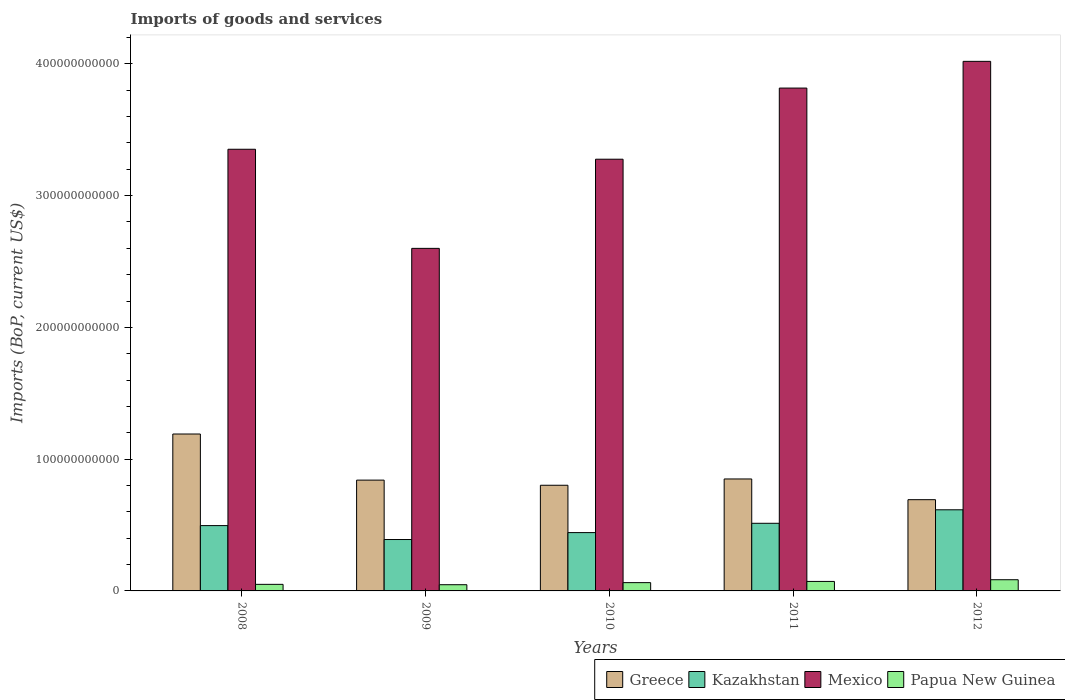How many groups of bars are there?
Your answer should be compact. 5. Are the number of bars per tick equal to the number of legend labels?
Your response must be concise. Yes. What is the label of the 1st group of bars from the left?
Provide a short and direct response. 2008. What is the amount spent on imports in Mexico in 2011?
Your response must be concise. 3.82e+11. Across all years, what is the maximum amount spent on imports in Mexico?
Offer a terse response. 4.02e+11. Across all years, what is the minimum amount spent on imports in Kazakhstan?
Offer a very short reply. 3.90e+1. In which year was the amount spent on imports in Papua New Guinea maximum?
Your response must be concise. 2012. What is the total amount spent on imports in Papua New Guinea in the graph?
Your answer should be very brief. 3.17e+1. What is the difference between the amount spent on imports in Kazakhstan in 2008 and that in 2012?
Keep it short and to the point. -1.20e+1. What is the difference between the amount spent on imports in Kazakhstan in 2008 and the amount spent on imports in Papua New Guinea in 2011?
Offer a terse response. 4.24e+1. What is the average amount spent on imports in Mexico per year?
Offer a terse response. 3.41e+11. In the year 2012, what is the difference between the amount spent on imports in Mexico and amount spent on imports in Greece?
Ensure brevity in your answer.  3.33e+11. In how many years, is the amount spent on imports in Kazakhstan greater than 160000000000 US$?
Keep it short and to the point. 0. What is the ratio of the amount spent on imports in Kazakhstan in 2009 to that in 2012?
Offer a terse response. 0.63. Is the difference between the amount spent on imports in Mexico in 2009 and 2010 greater than the difference between the amount spent on imports in Greece in 2009 and 2010?
Make the answer very short. No. What is the difference between the highest and the second highest amount spent on imports in Greece?
Provide a succinct answer. 3.41e+1. What is the difference between the highest and the lowest amount spent on imports in Kazakhstan?
Provide a succinct answer. 2.26e+1. What does the 1st bar from the left in 2009 represents?
Your response must be concise. Greece. What does the 3rd bar from the right in 2012 represents?
Provide a short and direct response. Kazakhstan. Is it the case that in every year, the sum of the amount spent on imports in Greece and amount spent on imports in Mexico is greater than the amount spent on imports in Kazakhstan?
Provide a short and direct response. Yes. How many bars are there?
Offer a very short reply. 20. Are all the bars in the graph horizontal?
Your answer should be very brief. No. What is the difference between two consecutive major ticks on the Y-axis?
Your response must be concise. 1.00e+11. Are the values on the major ticks of Y-axis written in scientific E-notation?
Give a very brief answer. No. Where does the legend appear in the graph?
Your answer should be very brief. Bottom right. How are the legend labels stacked?
Your response must be concise. Horizontal. What is the title of the graph?
Give a very brief answer. Imports of goods and services. What is the label or title of the X-axis?
Provide a short and direct response. Years. What is the label or title of the Y-axis?
Your answer should be very brief. Imports (BoP, current US$). What is the Imports (BoP, current US$) in Greece in 2008?
Provide a succinct answer. 1.19e+11. What is the Imports (BoP, current US$) of Kazakhstan in 2008?
Offer a terse response. 4.96e+1. What is the Imports (BoP, current US$) in Mexico in 2008?
Your answer should be very brief. 3.35e+11. What is the Imports (BoP, current US$) in Papua New Guinea in 2008?
Offer a terse response. 4.98e+09. What is the Imports (BoP, current US$) of Greece in 2009?
Make the answer very short. 8.41e+1. What is the Imports (BoP, current US$) in Kazakhstan in 2009?
Offer a very short reply. 3.90e+1. What is the Imports (BoP, current US$) in Mexico in 2009?
Keep it short and to the point. 2.60e+11. What is the Imports (BoP, current US$) in Papua New Guinea in 2009?
Ensure brevity in your answer.  4.71e+09. What is the Imports (BoP, current US$) of Greece in 2010?
Your answer should be very brief. 8.02e+1. What is the Imports (BoP, current US$) of Kazakhstan in 2010?
Give a very brief answer. 4.43e+1. What is the Imports (BoP, current US$) of Mexico in 2010?
Ensure brevity in your answer.  3.28e+11. What is the Imports (BoP, current US$) in Papua New Guinea in 2010?
Make the answer very short. 6.29e+09. What is the Imports (BoP, current US$) of Greece in 2011?
Offer a very short reply. 8.50e+1. What is the Imports (BoP, current US$) in Kazakhstan in 2011?
Provide a succinct answer. 5.13e+1. What is the Imports (BoP, current US$) of Mexico in 2011?
Give a very brief answer. 3.82e+11. What is the Imports (BoP, current US$) of Papua New Guinea in 2011?
Keep it short and to the point. 7.21e+09. What is the Imports (BoP, current US$) of Greece in 2012?
Offer a very short reply. 6.92e+1. What is the Imports (BoP, current US$) of Kazakhstan in 2012?
Offer a very short reply. 6.16e+1. What is the Imports (BoP, current US$) of Mexico in 2012?
Your answer should be very brief. 4.02e+11. What is the Imports (BoP, current US$) of Papua New Guinea in 2012?
Your answer should be compact. 8.50e+09. Across all years, what is the maximum Imports (BoP, current US$) in Greece?
Your response must be concise. 1.19e+11. Across all years, what is the maximum Imports (BoP, current US$) in Kazakhstan?
Give a very brief answer. 6.16e+1. Across all years, what is the maximum Imports (BoP, current US$) in Mexico?
Provide a succinct answer. 4.02e+11. Across all years, what is the maximum Imports (BoP, current US$) in Papua New Guinea?
Offer a terse response. 8.50e+09. Across all years, what is the minimum Imports (BoP, current US$) in Greece?
Provide a short and direct response. 6.92e+1. Across all years, what is the minimum Imports (BoP, current US$) in Kazakhstan?
Make the answer very short. 3.90e+1. Across all years, what is the minimum Imports (BoP, current US$) of Mexico?
Give a very brief answer. 2.60e+11. Across all years, what is the minimum Imports (BoP, current US$) in Papua New Guinea?
Your response must be concise. 4.71e+09. What is the total Imports (BoP, current US$) in Greece in the graph?
Your answer should be compact. 4.38e+11. What is the total Imports (BoP, current US$) in Kazakhstan in the graph?
Make the answer very short. 2.46e+11. What is the total Imports (BoP, current US$) of Mexico in the graph?
Ensure brevity in your answer.  1.71e+12. What is the total Imports (BoP, current US$) in Papua New Guinea in the graph?
Give a very brief answer. 3.17e+1. What is the difference between the Imports (BoP, current US$) in Greece in 2008 and that in 2009?
Your answer should be compact. 3.50e+1. What is the difference between the Imports (BoP, current US$) of Kazakhstan in 2008 and that in 2009?
Your answer should be compact. 1.06e+1. What is the difference between the Imports (BoP, current US$) in Mexico in 2008 and that in 2009?
Keep it short and to the point. 7.52e+1. What is the difference between the Imports (BoP, current US$) of Papua New Guinea in 2008 and that in 2009?
Your answer should be compact. 2.73e+08. What is the difference between the Imports (BoP, current US$) of Greece in 2008 and that in 2010?
Provide a succinct answer. 3.89e+1. What is the difference between the Imports (BoP, current US$) of Kazakhstan in 2008 and that in 2010?
Give a very brief answer. 5.31e+09. What is the difference between the Imports (BoP, current US$) in Mexico in 2008 and that in 2010?
Offer a very short reply. 7.56e+09. What is the difference between the Imports (BoP, current US$) of Papua New Guinea in 2008 and that in 2010?
Offer a terse response. -1.30e+09. What is the difference between the Imports (BoP, current US$) of Greece in 2008 and that in 2011?
Offer a terse response. 3.41e+1. What is the difference between the Imports (BoP, current US$) of Kazakhstan in 2008 and that in 2011?
Your response must be concise. -1.75e+09. What is the difference between the Imports (BoP, current US$) of Mexico in 2008 and that in 2011?
Your answer should be compact. -4.64e+1. What is the difference between the Imports (BoP, current US$) in Papua New Guinea in 2008 and that in 2011?
Provide a succinct answer. -2.22e+09. What is the difference between the Imports (BoP, current US$) of Greece in 2008 and that in 2012?
Ensure brevity in your answer.  4.98e+1. What is the difference between the Imports (BoP, current US$) of Kazakhstan in 2008 and that in 2012?
Make the answer very short. -1.20e+1. What is the difference between the Imports (BoP, current US$) in Mexico in 2008 and that in 2012?
Provide a succinct answer. -6.67e+1. What is the difference between the Imports (BoP, current US$) in Papua New Guinea in 2008 and that in 2012?
Give a very brief answer. -3.52e+09. What is the difference between the Imports (BoP, current US$) of Greece in 2009 and that in 2010?
Ensure brevity in your answer.  3.90e+09. What is the difference between the Imports (BoP, current US$) in Kazakhstan in 2009 and that in 2010?
Your response must be concise. -5.26e+09. What is the difference between the Imports (BoP, current US$) of Mexico in 2009 and that in 2010?
Your answer should be very brief. -6.77e+1. What is the difference between the Imports (BoP, current US$) of Papua New Guinea in 2009 and that in 2010?
Provide a succinct answer. -1.57e+09. What is the difference between the Imports (BoP, current US$) in Greece in 2009 and that in 2011?
Your answer should be compact. -8.84e+08. What is the difference between the Imports (BoP, current US$) in Kazakhstan in 2009 and that in 2011?
Offer a very short reply. -1.23e+1. What is the difference between the Imports (BoP, current US$) of Mexico in 2009 and that in 2011?
Provide a succinct answer. -1.22e+11. What is the difference between the Imports (BoP, current US$) of Papua New Guinea in 2009 and that in 2011?
Give a very brief answer. -2.49e+09. What is the difference between the Imports (BoP, current US$) of Greece in 2009 and that in 2012?
Provide a short and direct response. 1.48e+1. What is the difference between the Imports (BoP, current US$) of Kazakhstan in 2009 and that in 2012?
Give a very brief answer. -2.26e+1. What is the difference between the Imports (BoP, current US$) of Mexico in 2009 and that in 2012?
Offer a terse response. -1.42e+11. What is the difference between the Imports (BoP, current US$) of Papua New Guinea in 2009 and that in 2012?
Provide a succinct answer. -3.79e+09. What is the difference between the Imports (BoP, current US$) in Greece in 2010 and that in 2011?
Your answer should be very brief. -4.79e+09. What is the difference between the Imports (BoP, current US$) of Kazakhstan in 2010 and that in 2011?
Your answer should be very brief. -7.06e+09. What is the difference between the Imports (BoP, current US$) of Mexico in 2010 and that in 2011?
Keep it short and to the point. -5.40e+1. What is the difference between the Imports (BoP, current US$) of Papua New Guinea in 2010 and that in 2011?
Provide a short and direct response. -9.20e+08. What is the difference between the Imports (BoP, current US$) of Greece in 2010 and that in 2012?
Give a very brief answer. 1.09e+1. What is the difference between the Imports (BoP, current US$) of Kazakhstan in 2010 and that in 2012?
Offer a terse response. -1.73e+1. What is the difference between the Imports (BoP, current US$) of Mexico in 2010 and that in 2012?
Provide a succinct answer. -7.43e+1. What is the difference between the Imports (BoP, current US$) of Papua New Guinea in 2010 and that in 2012?
Offer a terse response. -2.21e+09. What is the difference between the Imports (BoP, current US$) of Greece in 2011 and that in 2012?
Give a very brief answer. 1.57e+1. What is the difference between the Imports (BoP, current US$) of Kazakhstan in 2011 and that in 2012?
Give a very brief answer. -1.02e+1. What is the difference between the Imports (BoP, current US$) of Mexico in 2011 and that in 2012?
Provide a succinct answer. -2.03e+1. What is the difference between the Imports (BoP, current US$) of Papua New Guinea in 2011 and that in 2012?
Provide a succinct answer. -1.29e+09. What is the difference between the Imports (BoP, current US$) of Greece in 2008 and the Imports (BoP, current US$) of Kazakhstan in 2009?
Keep it short and to the point. 8.01e+1. What is the difference between the Imports (BoP, current US$) in Greece in 2008 and the Imports (BoP, current US$) in Mexico in 2009?
Your answer should be very brief. -1.41e+11. What is the difference between the Imports (BoP, current US$) in Greece in 2008 and the Imports (BoP, current US$) in Papua New Guinea in 2009?
Ensure brevity in your answer.  1.14e+11. What is the difference between the Imports (BoP, current US$) of Kazakhstan in 2008 and the Imports (BoP, current US$) of Mexico in 2009?
Ensure brevity in your answer.  -2.10e+11. What is the difference between the Imports (BoP, current US$) of Kazakhstan in 2008 and the Imports (BoP, current US$) of Papua New Guinea in 2009?
Offer a very short reply. 4.49e+1. What is the difference between the Imports (BoP, current US$) of Mexico in 2008 and the Imports (BoP, current US$) of Papua New Guinea in 2009?
Ensure brevity in your answer.  3.30e+11. What is the difference between the Imports (BoP, current US$) of Greece in 2008 and the Imports (BoP, current US$) of Kazakhstan in 2010?
Give a very brief answer. 7.48e+1. What is the difference between the Imports (BoP, current US$) in Greece in 2008 and the Imports (BoP, current US$) in Mexico in 2010?
Make the answer very short. -2.09e+11. What is the difference between the Imports (BoP, current US$) of Greece in 2008 and the Imports (BoP, current US$) of Papua New Guinea in 2010?
Provide a short and direct response. 1.13e+11. What is the difference between the Imports (BoP, current US$) in Kazakhstan in 2008 and the Imports (BoP, current US$) in Mexico in 2010?
Provide a short and direct response. -2.78e+11. What is the difference between the Imports (BoP, current US$) in Kazakhstan in 2008 and the Imports (BoP, current US$) in Papua New Guinea in 2010?
Offer a terse response. 4.33e+1. What is the difference between the Imports (BoP, current US$) in Mexico in 2008 and the Imports (BoP, current US$) in Papua New Guinea in 2010?
Your answer should be very brief. 3.29e+11. What is the difference between the Imports (BoP, current US$) of Greece in 2008 and the Imports (BoP, current US$) of Kazakhstan in 2011?
Give a very brief answer. 6.77e+1. What is the difference between the Imports (BoP, current US$) of Greece in 2008 and the Imports (BoP, current US$) of Mexico in 2011?
Keep it short and to the point. -2.63e+11. What is the difference between the Imports (BoP, current US$) in Greece in 2008 and the Imports (BoP, current US$) in Papua New Guinea in 2011?
Offer a very short reply. 1.12e+11. What is the difference between the Imports (BoP, current US$) in Kazakhstan in 2008 and the Imports (BoP, current US$) in Mexico in 2011?
Ensure brevity in your answer.  -3.32e+11. What is the difference between the Imports (BoP, current US$) of Kazakhstan in 2008 and the Imports (BoP, current US$) of Papua New Guinea in 2011?
Provide a short and direct response. 4.24e+1. What is the difference between the Imports (BoP, current US$) of Mexico in 2008 and the Imports (BoP, current US$) of Papua New Guinea in 2011?
Offer a terse response. 3.28e+11. What is the difference between the Imports (BoP, current US$) in Greece in 2008 and the Imports (BoP, current US$) in Kazakhstan in 2012?
Your answer should be very brief. 5.75e+1. What is the difference between the Imports (BoP, current US$) of Greece in 2008 and the Imports (BoP, current US$) of Mexico in 2012?
Offer a terse response. -2.83e+11. What is the difference between the Imports (BoP, current US$) of Greece in 2008 and the Imports (BoP, current US$) of Papua New Guinea in 2012?
Give a very brief answer. 1.11e+11. What is the difference between the Imports (BoP, current US$) in Kazakhstan in 2008 and the Imports (BoP, current US$) in Mexico in 2012?
Offer a very short reply. -3.52e+11. What is the difference between the Imports (BoP, current US$) of Kazakhstan in 2008 and the Imports (BoP, current US$) of Papua New Guinea in 2012?
Provide a succinct answer. 4.11e+1. What is the difference between the Imports (BoP, current US$) of Mexico in 2008 and the Imports (BoP, current US$) of Papua New Guinea in 2012?
Provide a succinct answer. 3.27e+11. What is the difference between the Imports (BoP, current US$) of Greece in 2009 and the Imports (BoP, current US$) of Kazakhstan in 2010?
Give a very brief answer. 3.98e+1. What is the difference between the Imports (BoP, current US$) in Greece in 2009 and the Imports (BoP, current US$) in Mexico in 2010?
Offer a very short reply. -2.44e+11. What is the difference between the Imports (BoP, current US$) of Greece in 2009 and the Imports (BoP, current US$) of Papua New Guinea in 2010?
Offer a terse response. 7.78e+1. What is the difference between the Imports (BoP, current US$) of Kazakhstan in 2009 and the Imports (BoP, current US$) of Mexico in 2010?
Make the answer very short. -2.89e+11. What is the difference between the Imports (BoP, current US$) in Kazakhstan in 2009 and the Imports (BoP, current US$) in Papua New Guinea in 2010?
Your answer should be very brief. 3.27e+1. What is the difference between the Imports (BoP, current US$) of Mexico in 2009 and the Imports (BoP, current US$) of Papua New Guinea in 2010?
Your response must be concise. 2.54e+11. What is the difference between the Imports (BoP, current US$) in Greece in 2009 and the Imports (BoP, current US$) in Kazakhstan in 2011?
Keep it short and to the point. 3.28e+1. What is the difference between the Imports (BoP, current US$) of Greece in 2009 and the Imports (BoP, current US$) of Mexico in 2011?
Provide a succinct answer. -2.98e+11. What is the difference between the Imports (BoP, current US$) in Greece in 2009 and the Imports (BoP, current US$) in Papua New Guinea in 2011?
Your answer should be very brief. 7.69e+1. What is the difference between the Imports (BoP, current US$) in Kazakhstan in 2009 and the Imports (BoP, current US$) in Mexico in 2011?
Keep it short and to the point. -3.43e+11. What is the difference between the Imports (BoP, current US$) of Kazakhstan in 2009 and the Imports (BoP, current US$) of Papua New Guinea in 2011?
Make the answer very short. 3.18e+1. What is the difference between the Imports (BoP, current US$) in Mexico in 2009 and the Imports (BoP, current US$) in Papua New Guinea in 2011?
Your answer should be very brief. 2.53e+11. What is the difference between the Imports (BoP, current US$) of Greece in 2009 and the Imports (BoP, current US$) of Kazakhstan in 2012?
Your answer should be compact. 2.25e+1. What is the difference between the Imports (BoP, current US$) of Greece in 2009 and the Imports (BoP, current US$) of Mexico in 2012?
Provide a succinct answer. -3.18e+11. What is the difference between the Imports (BoP, current US$) in Greece in 2009 and the Imports (BoP, current US$) in Papua New Guinea in 2012?
Make the answer very short. 7.56e+1. What is the difference between the Imports (BoP, current US$) of Kazakhstan in 2009 and the Imports (BoP, current US$) of Mexico in 2012?
Provide a short and direct response. -3.63e+11. What is the difference between the Imports (BoP, current US$) in Kazakhstan in 2009 and the Imports (BoP, current US$) in Papua New Guinea in 2012?
Give a very brief answer. 3.05e+1. What is the difference between the Imports (BoP, current US$) of Mexico in 2009 and the Imports (BoP, current US$) of Papua New Guinea in 2012?
Your response must be concise. 2.51e+11. What is the difference between the Imports (BoP, current US$) of Greece in 2010 and the Imports (BoP, current US$) of Kazakhstan in 2011?
Provide a succinct answer. 2.89e+1. What is the difference between the Imports (BoP, current US$) in Greece in 2010 and the Imports (BoP, current US$) in Mexico in 2011?
Offer a very short reply. -3.01e+11. What is the difference between the Imports (BoP, current US$) in Greece in 2010 and the Imports (BoP, current US$) in Papua New Guinea in 2011?
Give a very brief answer. 7.30e+1. What is the difference between the Imports (BoP, current US$) in Kazakhstan in 2010 and the Imports (BoP, current US$) in Mexico in 2011?
Ensure brevity in your answer.  -3.37e+11. What is the difference between the Imports (BoP, current US$) of Kazakhstan in 2010 and the Imports (BoP, current US$) of Papua New Guinea in 2011?
Make the answer very short. 3.71e+1. What is the difference between the Imports (BoP, current US$) in Mexico in 2010 and the Imports (BoP, current US$) in Papua New Guinea in 2011?
Ensure brevity in your answer.  3.20e+11. What is the difference between the Imports (BoP, current US$) in Greece in 2010 and the Imports (BoP, current US$) in Kazakhstan in 2012?
Provide a succinct answer. 1.86e+1. What is the difference between the Imports (BoP, current US$) of Greece in 2010 and the Imports (BoP, current US$) of Mexico in 2012?
Provide a short and direct response. -3.22e+11. What is the difference between the Imports (BoP, current US$) in Greece in 2010 and the Imports (BoP, current US$) in Papua New Guinea in 2012?
Offer a terse response. 7.17e+1. What is the difference between the Imports (BoP, current US$) in Kazakhstan in 2010 and the Imports (BoP, current US$) in Mexico in 2012?
Your answer should be very brief. -3.58e+11. What is the difference between the Imports (BoP, current US$) in Kazakhstan in 2010 and the Imports (BoP, current US$) in Papua New Guinea in 2012?
Offer a very short reply. 3.58e+1. What is the difference between the Imports (BoP, current US$) in Mexico in 2010 and the Imports (BoP, current US$) in Papua New Guinea in 2012?
Give a very brief answer. 3.19e+11. What is the difference between the Imports (BoP, current US$) of Greece in 2011 and the Imports (BoP, current US$) of Kazakhstan in 2012?
Your answer should be compact. 2.34e+1. What is the difference between the Imports (BoP, current US$) of Greece in 2011 and the Imports (BoP, current US$) of Mexico in 2012?
Give a very brief answer. -3.17e+11. What is the difference between the Imports (BoP, current US$) of Greece in 2011 and the Imports (BoP, current US$) of Papua New Guinea in 2012?
Provide a short and direct response. 7.65e+1. What is the difference between the Imports (BoP, current US$) in Kazakhstan in 2011 and the Imports (BoP, current US$) in Mexico in 2012?
Keep it short and to the point. -3.51e+11. What is the difference between the Imports (BoP, current US$) of Kazakhstan in 2011 and the Imports (BoP, current US$) of Papua New Guinea in 2012?
Ensure brevity in your answer.  4.28e+1. What is the difference between the Imports (BoP, current US$) of Mexico in 2011 and the Imports (BoP, current US$) of Papua New Guinea in 2012?
Make the answer very short. 3.73e+11. What is the average Imports (BoP, current US$) in Greece per year?
Make the answer very short. 8.75e+1. What is the average Imports (BoP, current US$) in Kazakhstan per year?
Provide a short and direct response. 4.91e+1. What is the average Imports (BoP, current US$) in Mexico per year?
Offer a terse response. 3.41e+11. What is the average Imports (BoP, current US$) of Papua New Guinea per year?
Your answer should be very brief. 6.34e+09. In the year 2008, what is the difference between the Imports (BoP, current US$) in Greece and Imports (BoP, current US$) in Kazakhstan?
Your answer should be compact. 6.95e+1. In the year 2008, what is the difference between the Imports (BoP, current US$) of Greece and Imports (BoP, current US$) of Mexico?
Provide a succinct answer. -2.16e+11. In the year 2008, what is the difference between the Imports (BoP, current US$) in Greece and Imports (BoP, current US$) in Papua New Guinea?
Ensure brevity in your answer.  1.14e+11. In the year 2008, what is the difference between the Imports (BoP, current US$) of Kazakhstan and Imports (BoP, current US$) of Mexico?
Provide a succinct answer. -2.86e+11. In the year 2008, what is the difference between the Imports (BoP, current US$) in Kazakhstan and Imports (BoP, current US$) in Papua New Guinea?
Give a very brief answer. 4.46e+1. In the year 2008, what is the difference between the Imports (BoP, current US$) of Mexico and Imports (BoP, current US$) of Papua New Guinea?
Provide a succinct answer. 3.30e+11. In the year 2009, what is the difference between the Imports (BoP, current US$) of Greece and Imports (BoP, current US$) of Kazakhstan?
Your answer should be compact. 4.51e+1. In the year 2009, what is the difference between the Imports (BoP, current US$) in Greece and Imports (BoP, current US$) in Mexico?
Make the answer very short. -1.76e+11. In the year 2009, what is the difference between the Imports (BoP, current US$) of Greece and Imports (BoP, current US$) of Papua New Guinea?
Ensure brevity in your answer.  7.94e+1. In the year 2009, what is the difference between the Imports (BoP, current US$) of Kazakhstan and Imports (BoP, current US$) of Mexico?
Provide a short and direct response. -2.21e+11. In the year 2009, what is the difference between the Imports (BoP, current US$) in Kazakhstan and Imports (BoP, current US$) in Papua New Guinea?
Make the answer very short. 3.43e+1. In the year 2009, what is the difference between the Imports (BoP, current US$) of Mexico and Imports (BoP, current US$) of Papua New Guinea?
Offer a terse response. 2.55e+11. In the year 2010, what is the difference between the Imports (BoP, current US$) of Greece and Imports (BoP, current US$) of Kazakhstan?
Your answer should be very brief. 3.59e+1. In the year 2010, what is the difference between the Imports (BoP, current US$) in Greece and Imports (BoP, current US$) in Mexico?
Offer a terse response. -2.47e+11. In the year 2010, what is the difference between the Imports (BoP, current US$) of Greece and Imports (BoP, current US$) of Papua New Guinea?
Give a very brief answer. 7.39e+1. In the year 2010, what is the difference between the Imports (BoP, current US$) of Kazakhstan and Imports (BoP, current US$) of Mexico?
Give a very brief answer. -2.83e+11. In the year 2010, what is the difference between the Imports (BoP, current US$) in Kazakhstan and Imports (BoP, current US$) in Papua New Guinea?
Your answer should be compact. 3.80e+1. In the year 2010, what is the difference between the Imports (BoP, current US$) of Mexico and Imports (BoP, current US$) of Papua New Guinea?
Make the answer very short. 3.21e+11. In the year 2011, what is the difference between the Imports (BoP, current US$) of Greece and Imports (BoP, current US$) of Kazakhstan?
Give a very brief answer. 3.36e+1. In the year 2011, what is the difference between the Imports (BoP, current US$) of Greece and Imports (BoP, current US$) of Mexico?
Make the answer very short. -2.97e+11. In the year 2011, what is the difference between the Imports (BoP, current US$) of Greece and Imports (BoP, current US$) of Papua New Guinea?
Offer a very short reply. 7.78e+1. In the year 2011, what is the difference between the Imports (BoP, current US$) of Kazakhstan and Imports (BoP, current US$) of Mexico?
Ensure brevity in your answer.  -3.30e+11. In the year 2011, what is the difference between the Imports (BoP, current US$) in Kazakhstan and Imports (BoP, current US$) in Papua New Guinea?
Your answer should be compact. 4.41e+1. In the year 2011, what is the difference between the Imports (BoP, current US$) in Mexico and Imports (BoP, current US$) in Papua New Guinea?
Offer a terse response. 3.74e+11. In the year 2012, what is the difference between the Imports (BoP, current US$) of Greece and Imports (BoP, current US$) of Kazakhstan?
Provide a short and direct response. 7.67e+09. In the year 2012, what is the difference between the Imports (BoP, current US$) in Greece and Imports (BoP, current US$) in Mexico?
Keep it short and to the point. -3.33e+11. In the year 2012, what is the difference between the Imports (BoP, current US$) in Greece and Imports (BoP, current US$) in Papua New Guinea?
Your response must be concise. 6.07e+1. In the year 2012, what is the difference between the Imports (BoP, current US$) in Kazakhstan and Imports (BoP, current US$) in Mexico?
Keep it short and to the point. -3.40e+11. In the year 2012, what is the difference between the Imports (BoP, current US$) in Kazakhstan and Imports (BoP, current US$) in Papua New Guinea?
Give a very brief answer. 5.31e+1. In the year 2012, what is the difference between the Imports (BoP, current US$) of Mexico and Imports (BoP, current US$) of Papua New Guinea?
Provide a succinct answer. 3.93e+11. What is the ratio of the Imports (BoP, current US$) of Greece in 2008 to that in 2009?
Offer a very short reply. 1.42. What is the ratio of the Imports (BoP, current US$) in Kazakhstan in 2008 to that in 2009?
Keep it short and to the point. 1.27. What is the ratio of the Imports (BoP, current US$) in Mexico in 2008 to that in 2009?
Offer a very short reply. 1.29. What is the ratio of the Imports (BoP, current US$) of Papua New Guinea in 2008 to that in 2009?
Make the answer very short. 1.06. What is the ratio of the Imports (BoP, current US$) of Greece in 2008 to that in 2010?
Provide a short and direct response. 1.49. What is the ratio of the Imports (BoP, current US$) in Kazakhstan in 2008 to that in 2010?
Offer a terse response. 1.12. What is the ratio of the Imports (BoP, current US$) of Mexico in 2008 to that in 2010?
Ensure brevity in your answer.  1.02. What is the ratio of the Imports (BoP, current US$) in Papua New Guinea in 2008 to that in 2010?
Your response must be concise. 0.79. What is the ratio of the Imports (BoP, current US$) in Greece in 2008 to that in 2011?
Keep it short and to the point. 1.4. What is the ratio of the Imports (BoP, current US$) in Kazakhstan in 2008 to that in 2011?
Your answer should be compact. 0.97. What is the ratio of the Imports (BoP, current US$) in Mexico in 2008 to that in 2011?
Offer a very short reply. 0.88. What is the ratio of the Imports (BoP, current US$) in Papua New Guinea in 2008 to that in 2011?
Ensure brevity in your answer.  0.69. What is the ratio of the Imports (BoP, current US$) of Greece in 2008 to that in 2012?
Provide a succinct answer. 1.72. What is the ratio of the Imports (BoP, current US$) of Kazakhstan in 2008 to that in 2012?
Offer a terse response. 0.81. What is the ratio of the Imports (BoP, current US$) of Mexico in 2008 to that in 2012?
Keep it short and to the point. 0.83. What is the ratio of the Imports (BoP, current US$) of Papua New Guinea in 2008 to that in 2012?
Ensure brevity in your answer.  0.59. What is the ratio of the Imports (BoP, current US$) of Greece in 2009 to that in 2010?
Make the answer very short. 1.05. What is the ratio of the Imports (BoP, current US$) of Kazakhstan in 2009 to that in 2010?
Provide a succinct answer. 0.88. What is the ratio of the Imports (BoP, current US$) in Mexico in 2009 to that in 2010?
Your response must be concise. 0.79. What is the ratio of the Imports (BoP, current US$) of Papua New Guinea in 2009 to that in 2010?
Your answer should be compact. 0.75. What is the ratio of the Imports (BoP, current US$) in Kazakhstan in 2009 to that in 2011?
Offer a terse response. 0.76. What is the ratio of the Imports (BoP, current US$) in Mexico in 2009 to that in 2011?
Your answer should be very brief. 0.68. What is the ratio of the Imports (BoP, current US$) of Papua New Guinea in 2009 to that in 2011?
Keep it short and to the point. 0.65. What is the ratio of the Imports (BoP, current US$) in Greece in 2009 to that in 2012?
Ensure brevity in your answer.  1.21. What is the ratio of the Imports (BoP, current US$) of Kazakhstan in 2009 to that in 2012?
Keep it short and to the point. 0.63. What is the ratio of the Imports (BoP, current US$) in Mexico in 2009 to that in 2012?
Offer a terse response. 0.65. What is the ratio of the Imports (BoP, current US$) of Papua New Guinea in 2009 to that in 2012?
Your answer should be very brief. 0.55. What is the ratio of the Imports (BoP, current US$) of Greece in 2010 to that in 2011?
Offer a terse response. 0.94. What is the ratio of the Imports (BoP, current US$) in Kazakhstan in 2010 to that in 2011?
Make the answer very short. 0.86. What is the ratio of the Imports (BoP, current US$) of Mexico in 2010 to that in 2011?
Keep it short and to the point. 0.86. What is the ratio of the Imports (BoP, current US$) in Papua New Guinea in 2010 to that in 2011?
Ensure brevity in your answer.  0.87. What is the ratio of the Imports (BoP, current US$) of Greece in 2010 to that in 2012?
Give a very brief answer. 1.16. What is the ratio of the Imports (BoP, current US$) of Kazakhstan in 2010 to that in 2012?
Provide a succinct answer. 0.72. What is the ratio of the Imports (BoP, current US$) of Mexico in 2010 to that in 2012?
Offer a terse response. 0.82. What is the ratio of the Imports (BoP, current US$) of Papua New Guinea in 2010 to that in 2012?
Provide a short and direct response. 0.74. What is the ratio of the Imports (BoP, current US$) in Greece in 2011 to that in 2012?
Offer a very short reply. 1.23. What is the ratio of the Imports (BoP, current US$) in Kazakhstan in 2011 to that in 2012?
Ensure brevity in your answer.  0.83. What is the ratio of the Imports (BoP, current US$) of Mexico in 2011 to that in 2012?
Your answer should be very brief. 0.95. What is the ratio of the Imports (BoP, current US$) in Papua New Guinea in 2011 to that in 2012?
Your answer should be compact. 0.85. What is the difference between the highest and the second highest Imports (BoP, current US$) of Greece?
Provide a succinct answer. 3.41e+1. What is the difference between the highest and the second highest Imports (BoP, current US$) in Kazakhstan?
Offer a terse response. 1.02e+1. What is the difference between the highest and the second highest Imports (BoP, current US$) in Mexico?
Your response must be concise. 2.03e+1. What is the difference between the highest and the second highest Imports (BoP, current US$) in Papua New Guinea?
Provide a succinct answer. 1.29e+09. What is the difference between the highest and the lowest Imports (BoP, current US$) of Greece?
Provide a short and direct response. 4.98e+1. What is the difference between the highest and the lowest Imports (BoP, current US$) of Kazakhstan?
Offer a very short reply. 2.26e+1. What is the difference between the highest and the lowest Imports (BoP, current US$) of Mexico?
Keep it short and to the point. 1.42e+11. What is the difference between the highest and the lowest Imports (BoP, current US$) of Papua New Guinea?
Make the answer very short. 3.79e+09. 